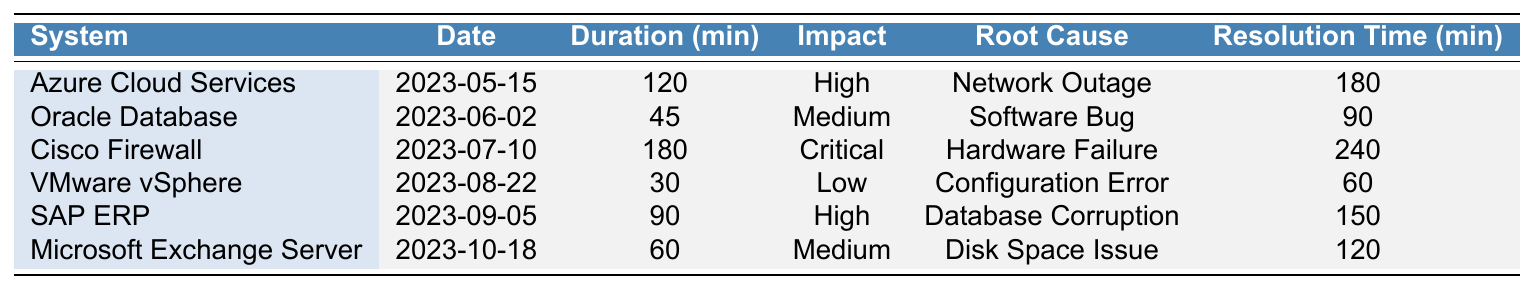What was the longest downtime incident and when did it occur? The longest downtime incident is 180 minutes for the Cisco Firewall on July 10, 2023.
Answer: 180 minutes on July 10, 2023 Which system had the lowest impact level during downtime? The VMware vSphere incident had the lowest impact level categorized as 'Low'.
Answer: VMware vSphere How many incidents had a resolution time longer than 120 minutes? By reviewing the resolution times in the table, only the Cisco Firewall (240 minutes) and Azure Cloud Services (180 minutes) had resolution times longer than 120 minutes, resulting in two incidents.
Answer: 2 incidents What is the average duration of all downtime incidents? The total duration is (120 + 45 + 180 + 30 + 90 + 60) = 525 minutes, and there are 6 incidents. Thus, the average duration is 525/6 = 87.5 minutes.
Answer: 87.5 minutes Was there an incident that lasted less than 60 minutes, and if so, what system was it? Yes, the VMware vSphere incident lasted 30 minutes, which is less than 60 minutes.
Answer: Yes, VMware vSphere What is the total resolution time for all incidents? The total resolution time is calculated by adding all resolution times: (180 + 90 + 240 + 60 + 150 + 120) = 840 minutes.
Answer: 840 minutes Which incident had the highest impact and what was its root cause? The Cisco Firewall incident had the highest impact categorized as 'Critical', and the root cause was a 'Hardware Failure'.
Answer: Cisco Firewall, Hardware Failure How does the resolution time of Azure Cloud Services compare to the average resolution time of all incidents? The resolution time for Azure Cloud Services is 180 minutes, while the average resolution time is (840/6) = 140 minutes. Since 180 > 140, Azure's resolution time is higher than average.
Answer: Higher than average Were there more incidents caused by 'Network Outage' or 'Hardware Failure'? There is 1 incident for 'Network Outage' (Azure Cloud Services) and 1 incident for 'Hardware Failure' (Cisco Firewall), resulting in an equal count of incidents for these root causes.
Answer: Equal What was the total downtime duration for incidents categorized with 'High' impact? The total downtime duration for high-impact incidents consists of those for Azure Cloud Services (120 minutes) and SAP ERP (90 minutes), totaling to 120 + 90 = 210 minutes.
Answer: 210 minutes 